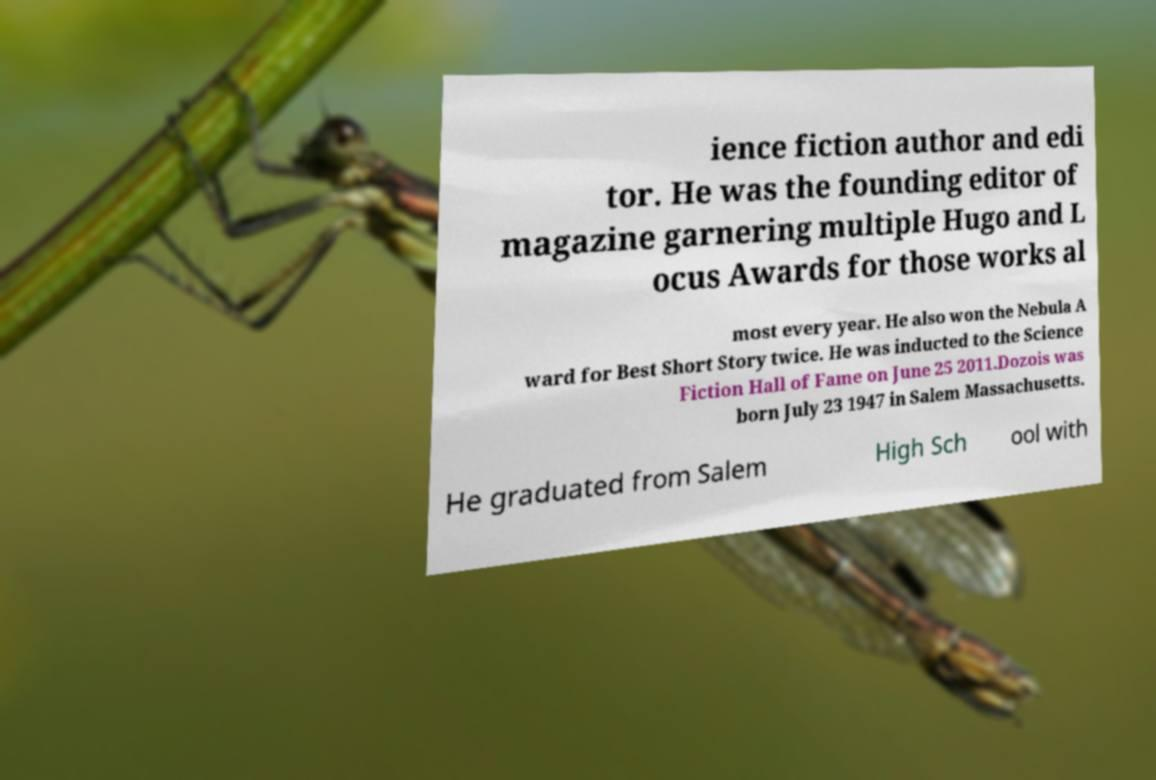I need the written content from this picture converted into text. Can you do that? ience fiction author and edi tor. He was the founding editor of magazine garnering multiple Hugo and L ocus Awards for those works al most every year. He also won the Nebula A ward for Best Short Story twice. He was inducted to the Science Fiction Hall of Fame on June 25 2011.Dozois was born July 23 1947 in Salem Massachusetts. He graduated from Salem High Sch ool with 